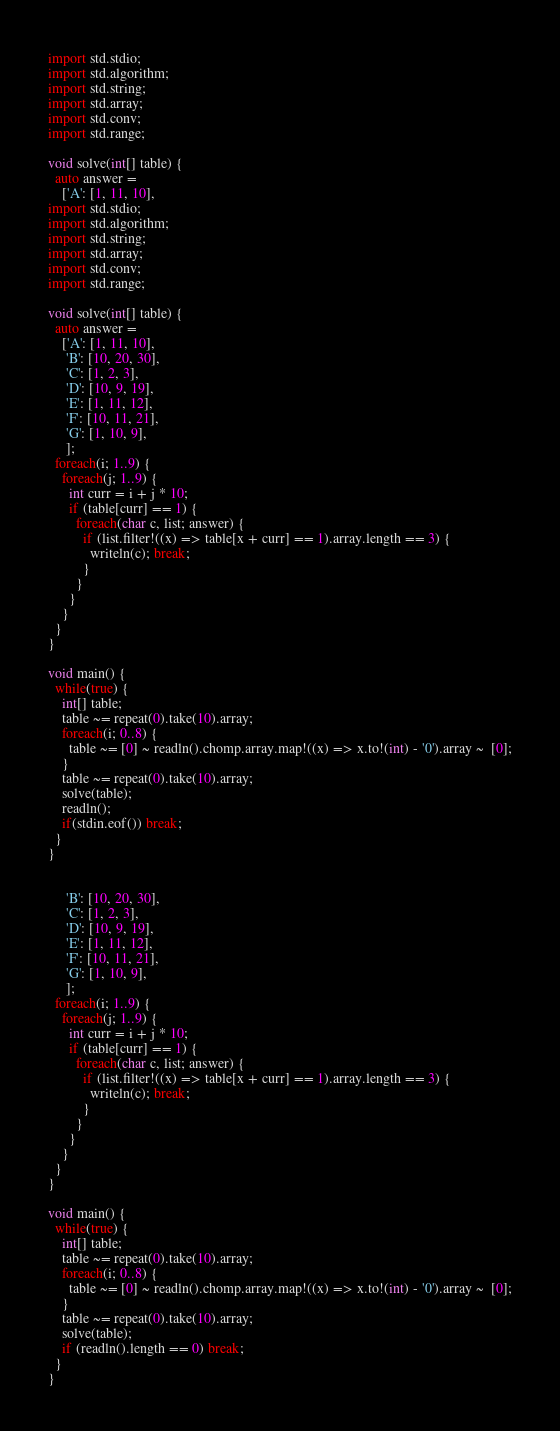<code> <loc_0><loc_0><loc_500><loc_500><_D_>
import std.stdio;
import std.algorithm;
import std.string;
import std.array;
import std.conv;
import std.range;

void solve(int[] table) {
  auto answer =
    ['A': [1, 11, 10],
import std.stdio;
import std.algorithm;
import std.string;
import std.array;
import std.conv;
import std.range;

void solve(int[] table) {
  auto answer =
    ['A': [1, 11, 10],
     'B': [10, 20, 30],
     'C': [1, 2, 3],
     'D': [10, 9, 19],
     'E': [1, 11, 12],
     'F': [10, 11, 21],
     'G': [1, 10, 9],
     ];
  foreach(i; 1..9) {
    foreach(j; 1..9) {
      int curr = i + j * 10;
      if (table[curr] == 1) {
        foreach(char c, list; answer) {
          if (list.filter!((x) => table[x + curr] == 1).array.length == 3) {
            writeln(c); break;
          }
        }
      }
    }
  }
}

void main() {
  while(true) {
    int[] table;
    table ~= repeat(0).take(10).array;
    foreach(i; 0..8) {
      table ~= [0] ~ readln().chomp.array.map!((x) => x.to!(int) - '0').array ~  [0];
    }
    table ~= repeat(0).take(10).array;
    solve(table);
    readln();
    if(stdin.eof()) break;
  }
}


     'B': [10, 20, 30],
     'C': [1, 2, 3],
     'D': [10, 9, 19],
     'E': [1, 11, 12],
     'F': [10, 11, 21],
     'G': [1, 10, 9],
     ];
  foreach(i; 1..9) {
    foreach(j; 1..9) {
      int curr = i + j * 10;
      if (table[curr] == 1) {
        foreach(char c, list; answer) {
          if (list.filter!((x) => table[x + curr] == 1).array.length == 3) {
            writeln(c); break;
          }
        }
      }
    }
  }
}

void main() {
  while(true) {
    int[] table;
    table ~= repeat(0).take(10).array;
    foreach(i; 0..8) {
      table ~= [0] ~ readln().chomp.array.map!((x) => x.to!(int) - '0').array ~  [0];
    }
    table ~= repeat(0).take(10).array;
    solve(table);
    if (readln().length == 0) break;
  }
}</code> 